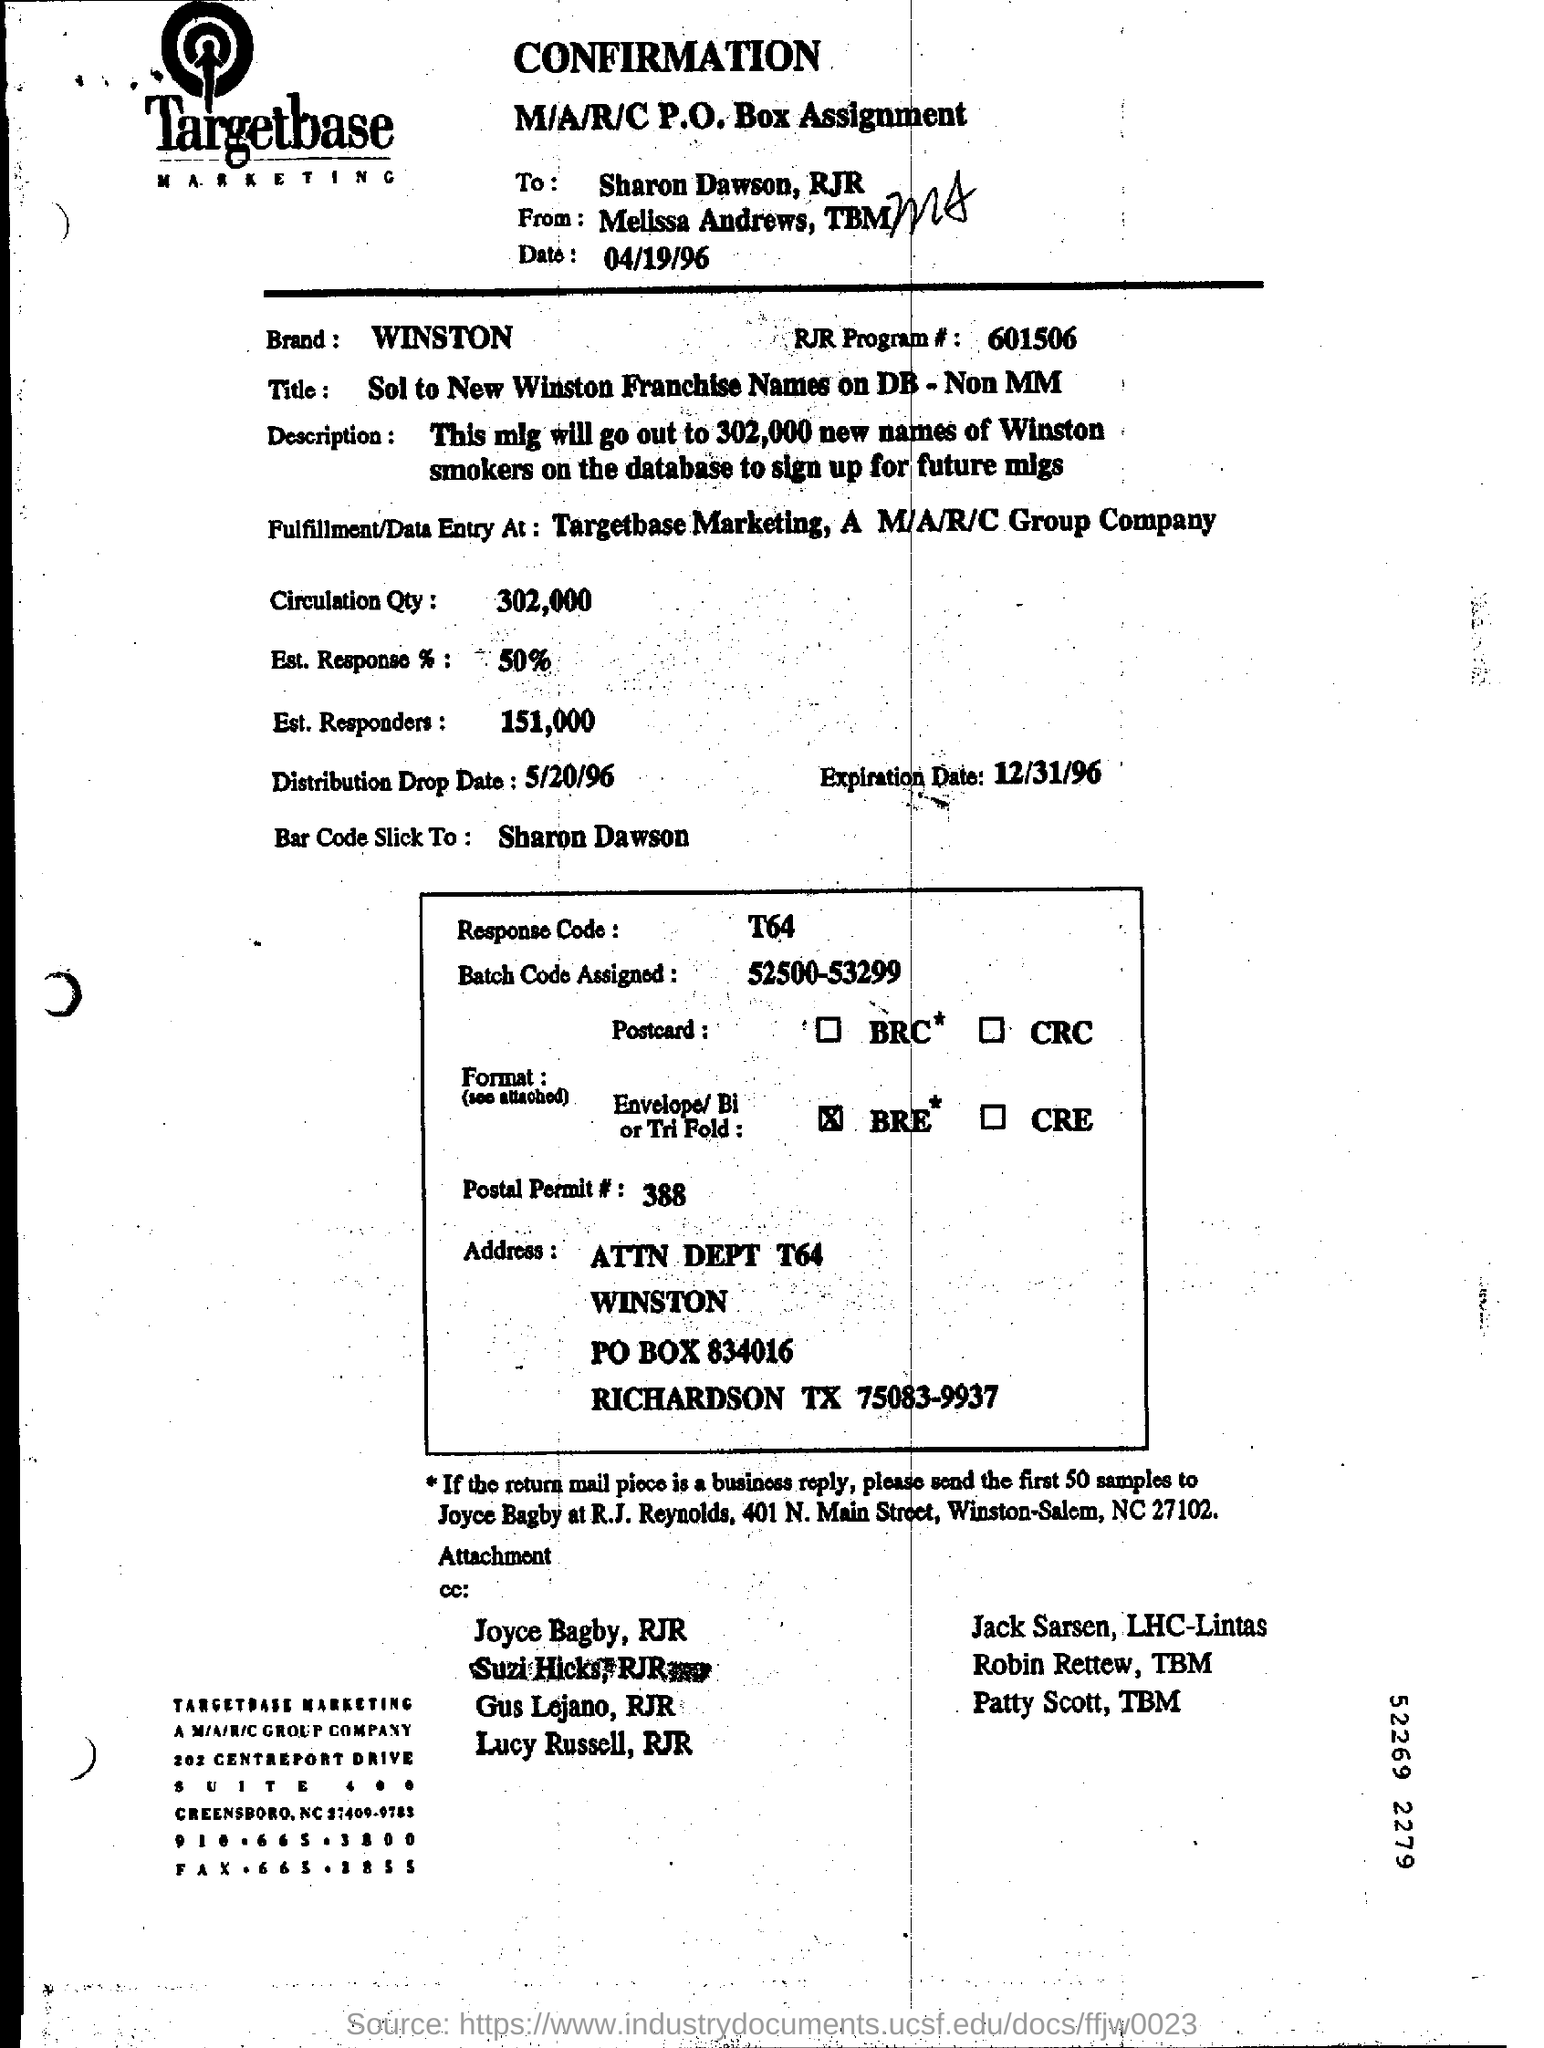Give some essential details in this illustration. The expiration date is December 31, 1996. The addressee of this message is Sharon Dawson, and it is addressed to her by RJR. The brand mentioned in the form is WINSTON. What is the date of April 19, 1996? WINSTON is a brand known for its high-quality and reliable products. 